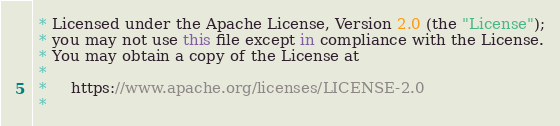Convert code to text. <code><loc_0><loc_0><loc_500><loc_500><_Kotlin_> * Licensed under the Apache License, Version 2.0 (the "License");
 * you may not use this file except in compliance with the License.
 * You may obtain a copy of the License at
 *
 *     https://www.apache.org/licenses/LICENSE-2.0
 *</code> 